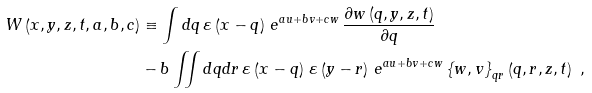Convert formula to latex. <formula><loc_0><loc_0><loc_500><loc_500>W \left ( x , y , z , t , a , b , c \right ) & \equiv \int d q \, \varepsilon \left ( x - q \right ) \, e ^ { a u + b v + c w } \, \frac { \partial w \left ( q , y , z , t \right ) } { \partial q } \\ & - b \iint d q d r \, \varepsilon \left ( x - q \right ) \, \varepsilon \left ( y - r \right ) \, e ^ { a u + b v + c w } \left \{ w , v \right \} _ { q r } \left ( q , r , z , t \right ) \ ,</formula> 